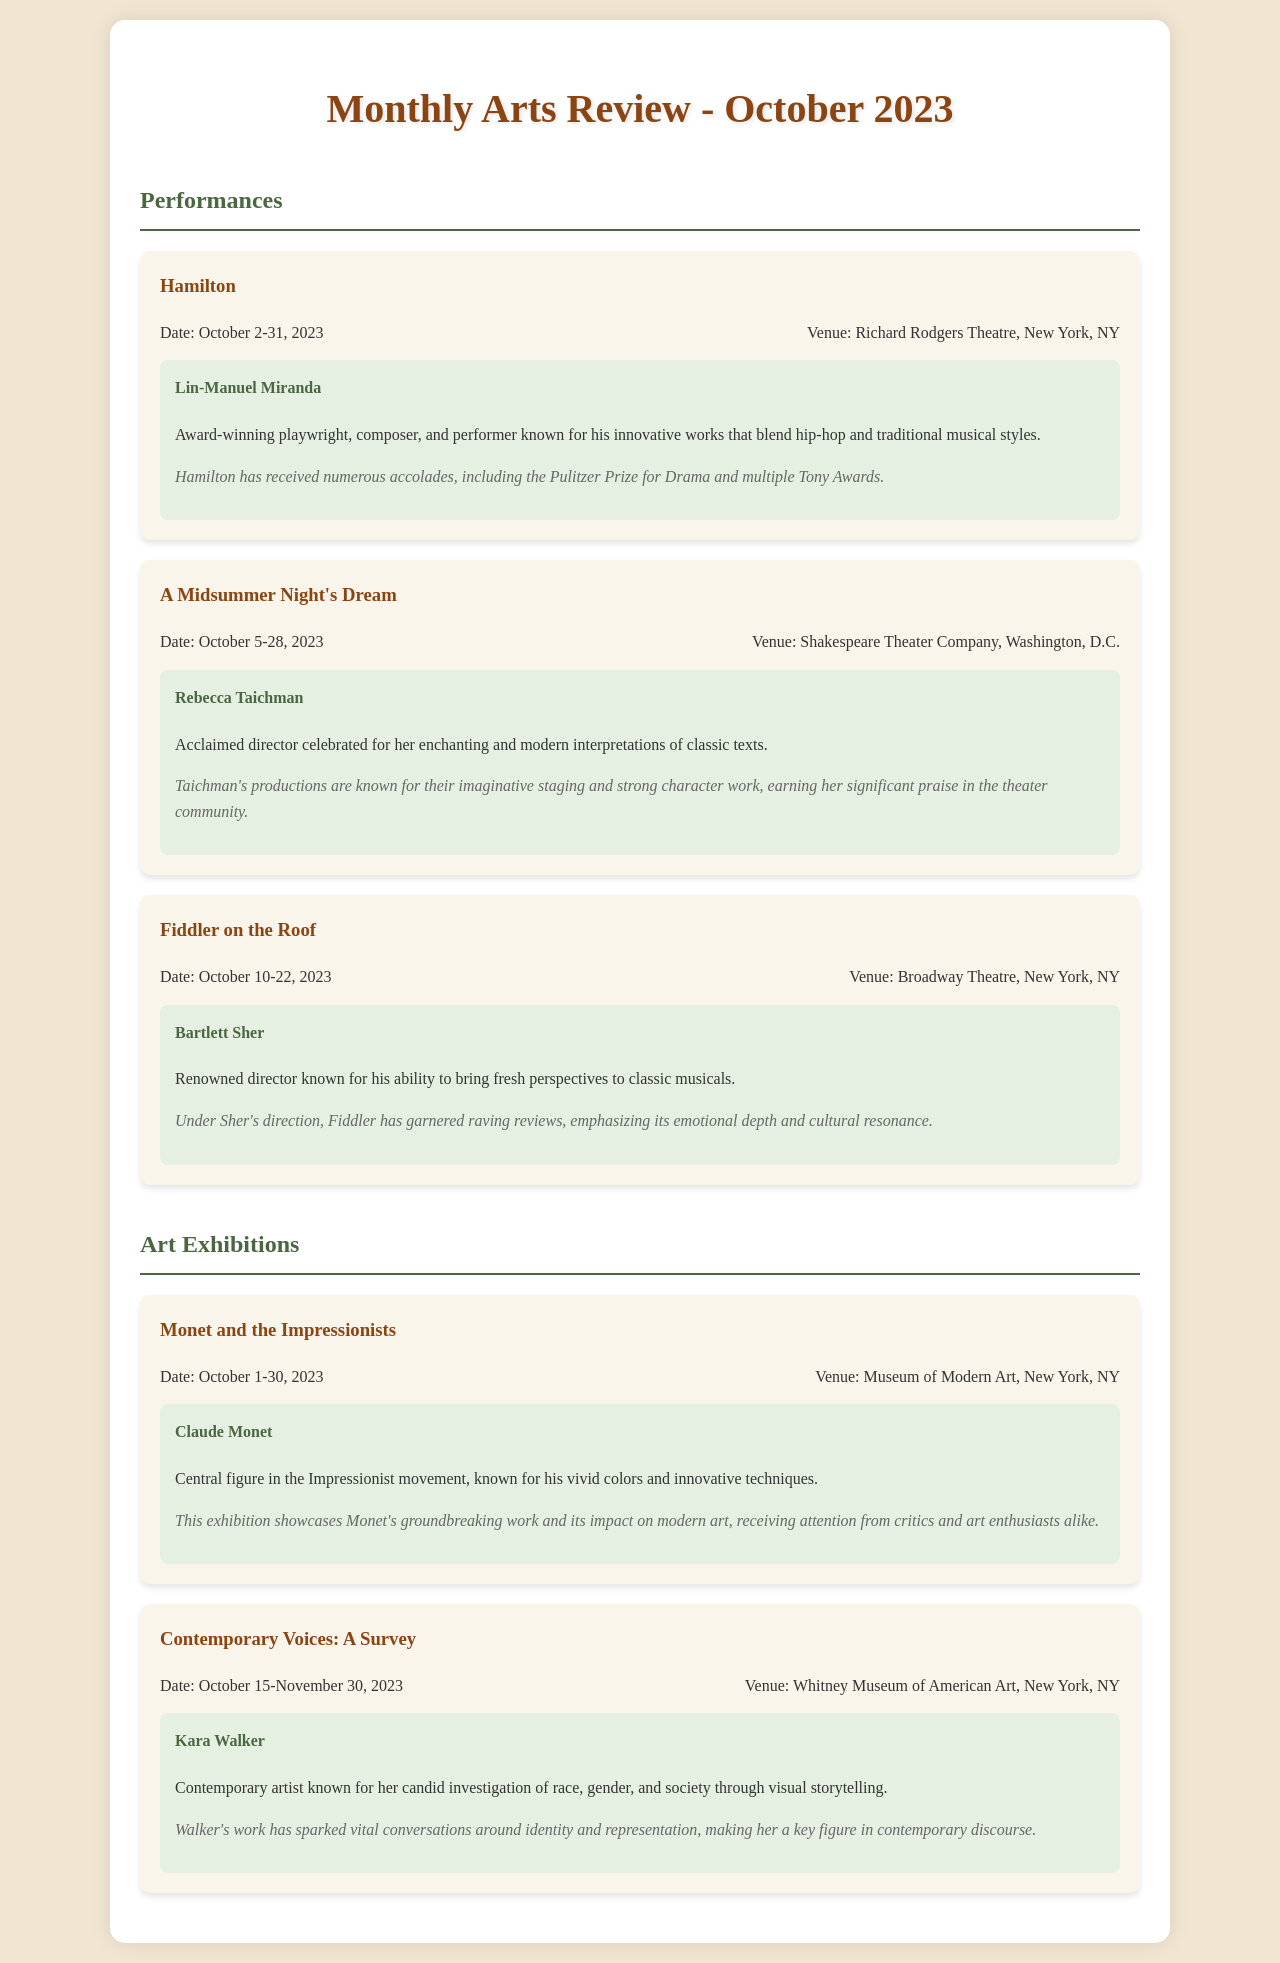What is the title of the first performance listed? The document lists "Hamilton" as the first performance.
Answer: Hamilton Who is the director of "A Midsummer Night's Dream"? The director listed for "A Midsummer Night's Dream" is Rebecca Taichman.
Answer: Rebecca Taichman What are the attendance dates for "Fiddler on the Roof"? The attendance dates for "Fiddler on the Roof" are from October 10 to October 22, 2023.
Answer: October 10-22, 2023 Which venue is hosting "Monet and the Impressionists"? The exhibition "Monet and the Impressionists" is being held at the Museum of Modern Art.
Answer: Museum of Modern Art How long is the "Contemporary Voices: A Survey" exhibition open? The exhibition is open from October 15 to November 30, 2023, which is a duration of 46 days.
Answer: 46 days What is a notable accolade received by "Hamilton"? Hamilton has received numerous accolades, including the Pulitzer Prize for Drama.
Answer: Pulitzer Prize for Drama Who is the central figure of the exhibition "Monet and the Impressionists"? The central figure of the exhibition is Claude Monet.
Answer: Claude Monet What is the genre of the performance "Fiddler on the Roof"? "Fiddler on the Roof" is classified as a musical.
Answer: Musical 